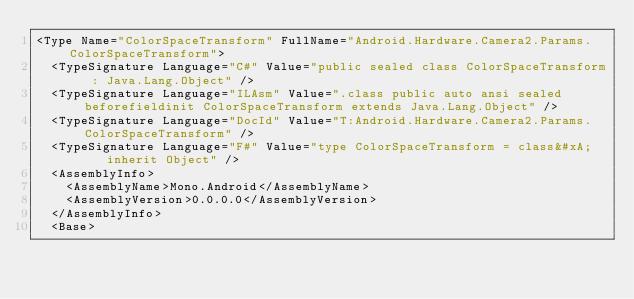Convert code to text. <code><loc_0><loc_0><loc_500><loc_500><_XML_><Type Name="ColorSpaceTransform" FullName="Android.Hardware.Camera2.Params.ColorSpaceTransform">
  <TypeSignature Language="C#" Value="public sealed class ColorSpaceTransform : Java.Lang.Object" />
  <TypeSignature Language="ILAsm" Value=".class public auto ansi sealed beforefieldinit ColorSpaceTransform extends Java.Lang.Object" />
  <TypeSignature Language="DocId" Value="T:Android.Hardware.Camera2.Params.ColorSpaceTransform" />
  <TypeSignature Language="F#" Value="type ColorSpaceTransform = class&#xA;    inherit Object" />
  <AssemblyInfo>
    <AssemblyName>Mono.Android</AssemblyName>
    <AssemblyVersion>0.0.0.0</AssemblyVersion>
  </AssemblyInfo>
  <Base></code> 